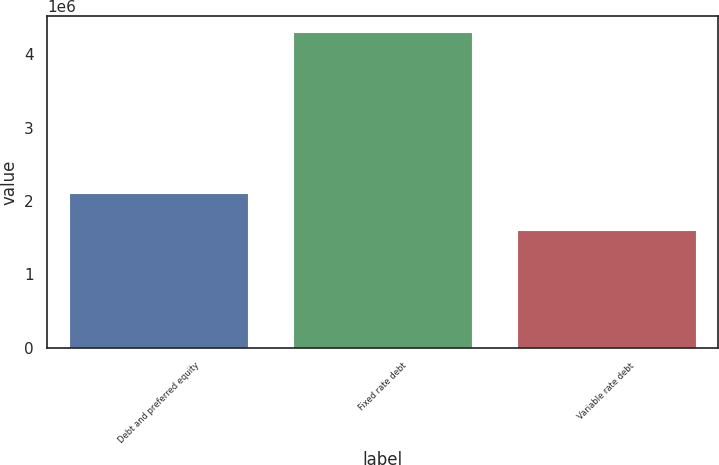Convert chart. <chart><loc_0><loc_0><loc_500><loc_500><bar_chart><fcel>Debt and preferred equity<fcel>Fixed rate debt<fcel>Variable rate debt<nl><fcel>2.11404e+06<fcel>4.30516e+06<fcel>1.60543e+06<nl></chart> 